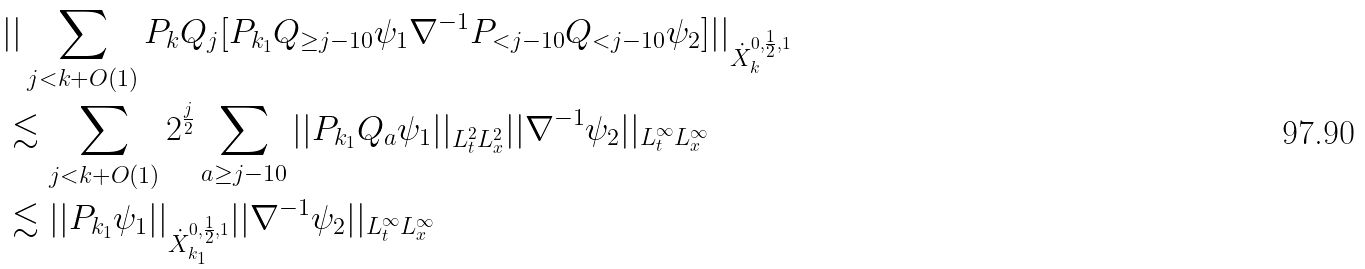<formula> <loc_0><loc_0><loc_500><loc_500>& | | \sum _ { j < k + O ( 1 ) } P _ { k } Q _ { j } [ P _ { k _ { 1 } } Q _ { \geq j - 1 0 } \psi _ { 1 } \nabla ^ { - 1 } P _ { < j - 1 0 } Q _ { < j - 1 0 } \psi _ { 2 } ] | | _ { \dot { X } _ { k } ^ { 0 , \frac { 1 } { 2 } , 1 } } \\ & \lesssim \sum _ { j < k + O ( 1 ) } 2 ^ { \frac { j } { 2 } } \sum _ { a \geq j - 1 0 } | | P _ { k _ { 1 } } Q _ { a } \psi _ { 1 } | | _ { L _ { t } ^ { 2 } L _ { x } ^ { 2 } } | | \nabla ^ { - 1 } \psi _ { 2 } | | _ { L _ { t } ^ { \infty } L _ { x } ^ { \infty } } \\ & \lesssim | | P _ { k _ { 1 } } \psi _ { 1 } | | _ { \dot { X } _ { k _ { 1 } } ^ { 0 , \frac { 1 } { 2 } , 1 } } | | \nabla ^ { - 1 } \psi _ { 2 } | | _ { L _ { t } ^ { \infty } L _ { x } ^ { \infty } } \\</formula> 